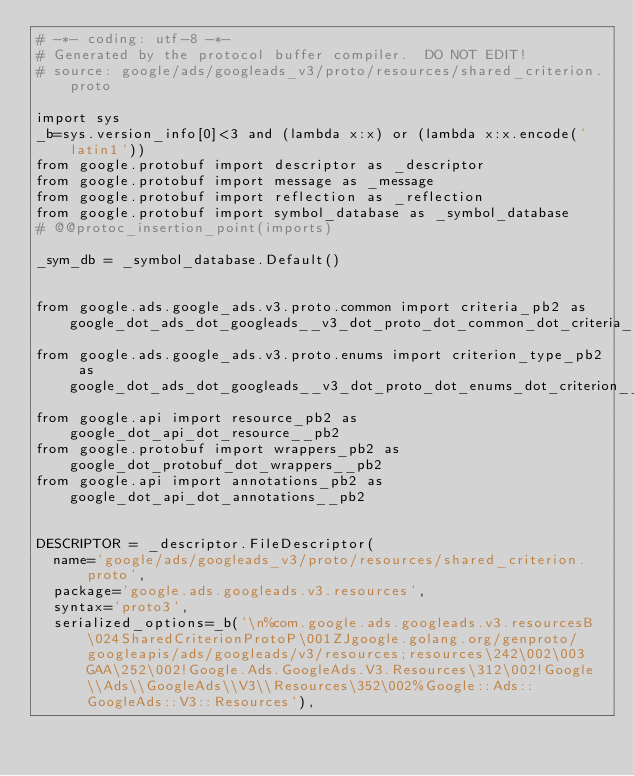Convert code to text. <code><loc_0><loc_0><loc_500><loc_500><_Python_># -*- coding: utf-8 -*-
# Generated by the protocol buffer compiler.  DO NOT EDIT!
# source: google/ads/googleads_v3/proto/resources/shared_criterion.proto

import sys
_b=sys.version_info[0]<3 and (lambda x:x) or (lambda x:x.encode('latin1'))
from google.protobuf import descriptor as _descriptor
from google.protobuf import message as _message
from google.protobuf import reflection as _reflection
from google.protobuf import symbol_database as _symbol_database
# @@protoc_insertion_point(imports)

_sym_db = _symbol_database.Default()


from google.ads.google_ads.v3.proto.common import criteria_pb2 as google_dot_ads_dot_googleads__v3_dot_proto_dot_common_dot_criteria__pb2
from google.ads.google_ads.v3.proto.enums import criterion_type_pb2 as google_dot_ads_dot_googleads__v3_dot_proto_dot_enums_dot_criterion__type__pb2
from google.api import resource_pb2 as google_dot_api_dot_resource__pb2
from google.protobuf import wrappers_pb2 as google_dot_protobuf_dot_wrappers__pb2
from google.api import annotations_pb2 as google_dot_api_dot_annotations__pb2


DESCRIPTOR = _descriptor.FileDescriptor(
  name='google/ads/googleads_v3/proto/resources/shared_criterion.proto',
  package='google.ads.googleads.v3.resources',
  syntax='proto3',
  serialized_options=_b('\n%com.google.ads.googleads.v3.resourcesB\024SharedCriterionProtoP\001ZJgoogle.golang.org/genproto/googleapis/ads/googleads/v3/resources;resources\242\002\003GAA\252\002!Google.Ads.GoogleAds.V3.Resources\312\002!Google\\Ads\\GoogleAds\\V3\\Resources\352\002%Google::Ads::GoogleAds::V3::Resources'),</code> 